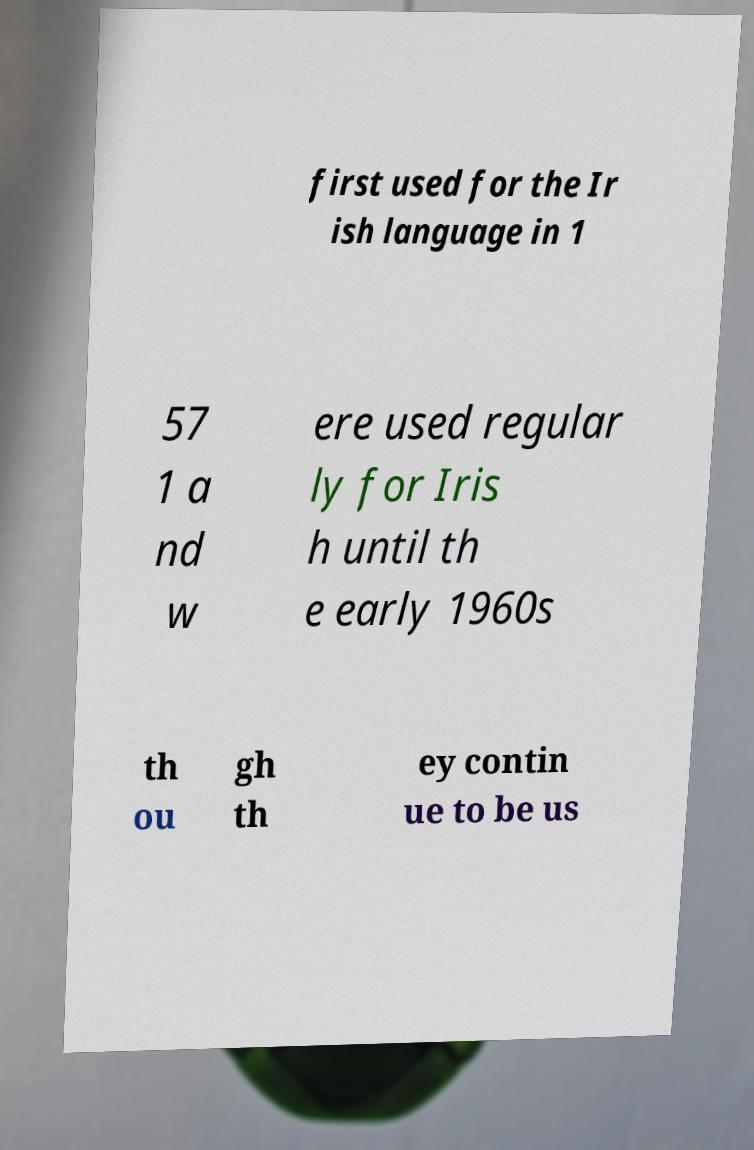Can you accurately transcribe the text from the provided image for me? first used for the Ir ish language in 1 57 1 a nd w ere used regular ly for Iris h until th e early 1960s th ou gh th ey contin ue to be us 